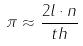Convert formula to latex. <formula><loc_0><loc_0><loc_500><loc_500>\pi \approx \frac { 2 l \cdot n } { t h }</formula> 